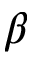<formula> <loc_0><loc_0><loc_500><loc_500>\beta</formula> 